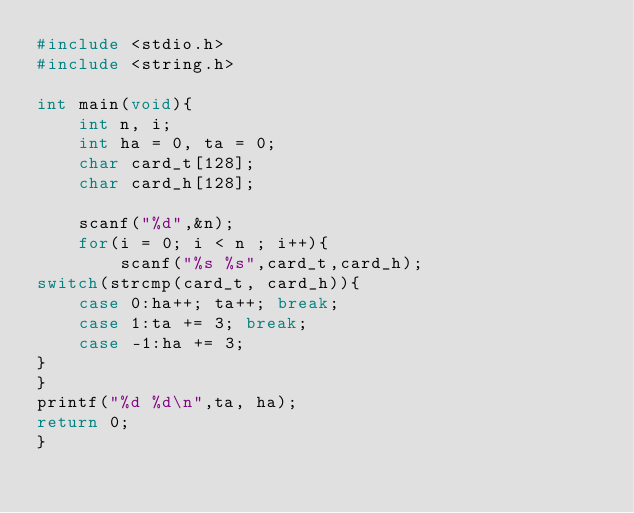Convert code to text. <code><loc_0><loc_0><loc_500><loc_500><_C_>#include <stdio.h>
#include <string.h>

int main(void){
	int n, i;
	int ha = 0, ta = 0;
	char card_t[128];
	char card_h[128];

	scanf("%d",&n);
	for(i = 0; i < n ; i++){
		scanf("%s %s",card_t,card_h);
switch(strcmp(card_t, card_h)){
	case 0:ha++; ta++; break;
	case 1:ta += 3; break;
	case -1:ha += 3; 
}
}
printf("%d %d\n",ta, ha);
return 0;
}</code> 